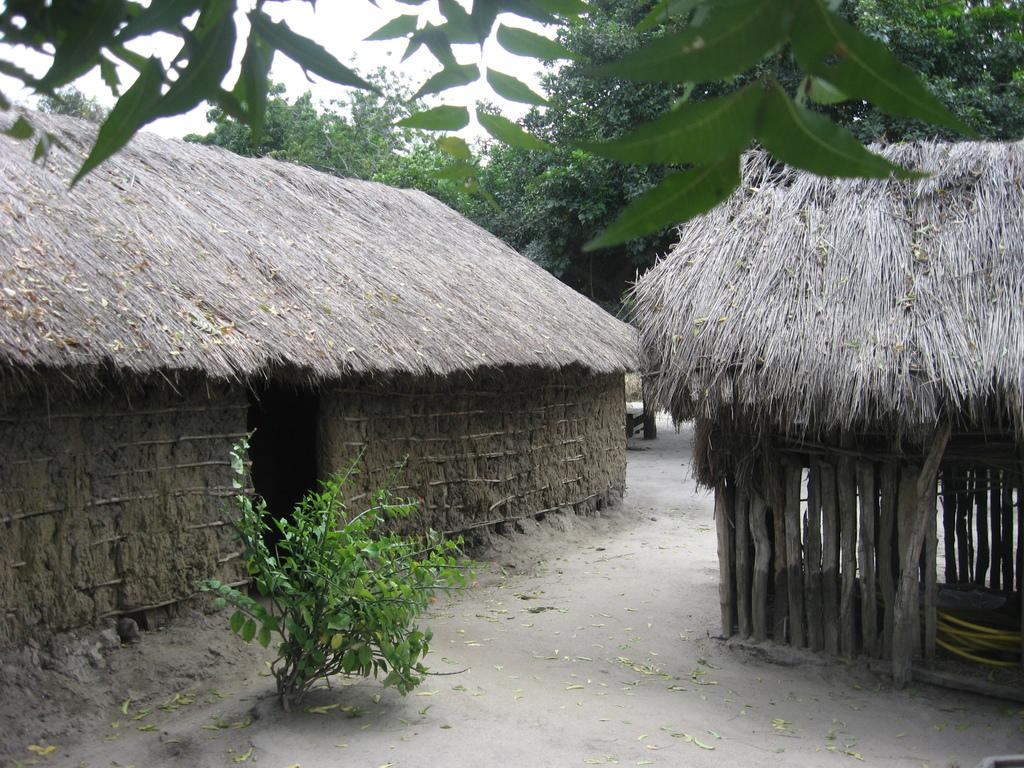How many huts can be seen in the image? There are two huts in the image. What is located in front of one of the huts? There is a plant in front of one of the huts. What can be seen in the background of the image? There are trees and the sky visible in the background of the image. Where is the throne located in the image? There is no throne present in the image. How many drops of water can be seen falling from the sky in the image? The image does not show any drops of water falling from the sky; it only shows the sky in the background. 